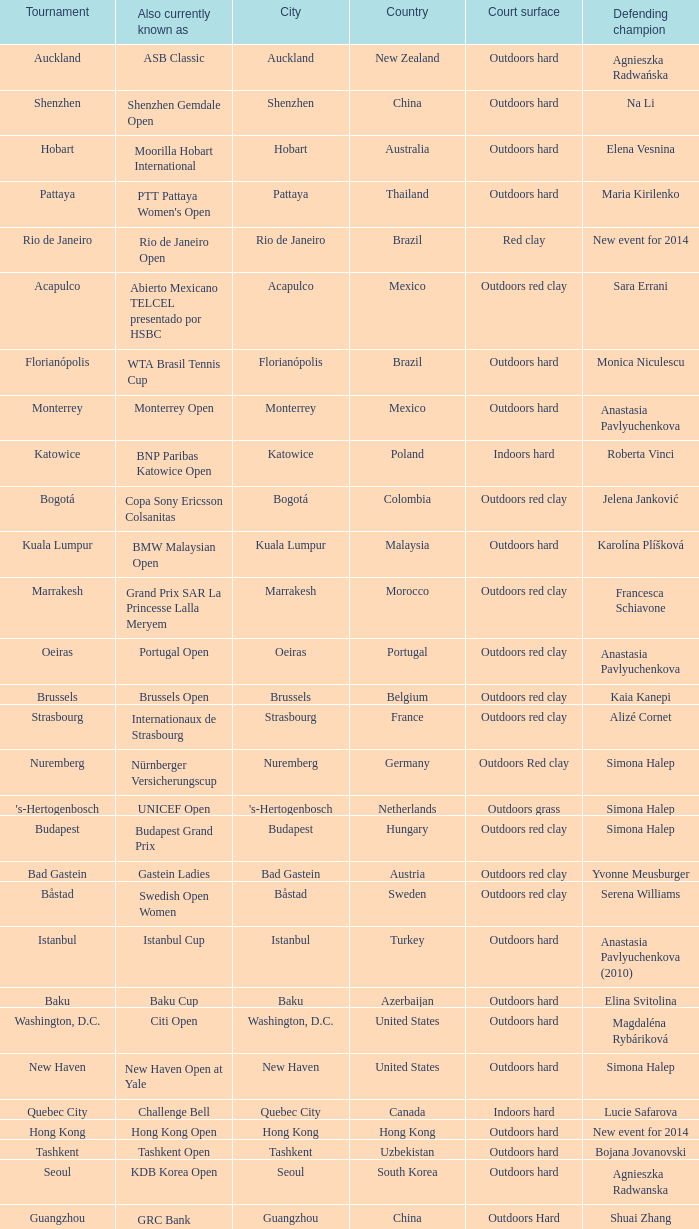How many current titleholders from thailand? 1.0. 